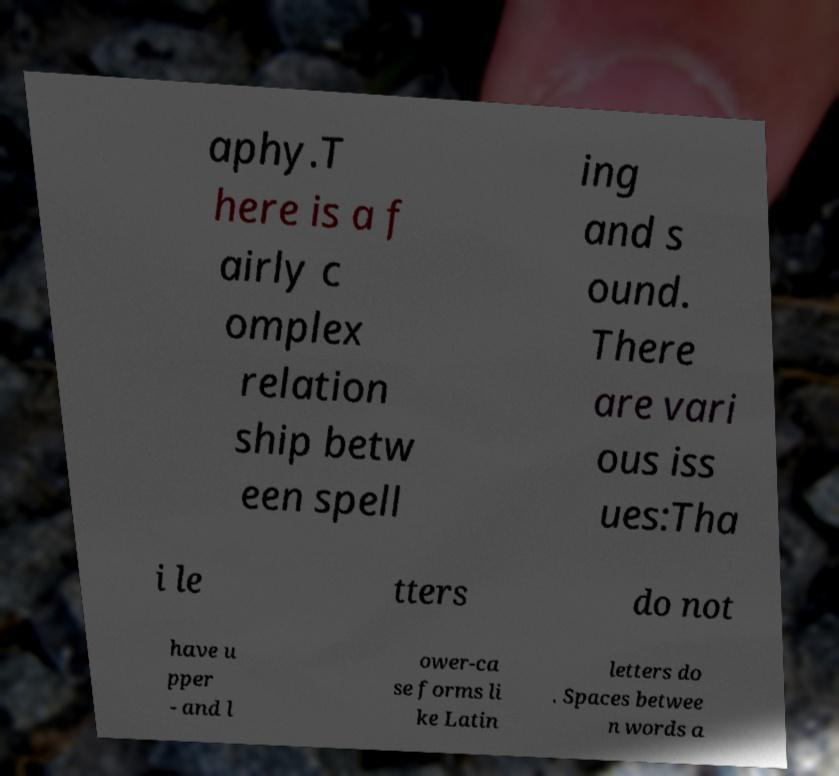Could you extract and type out the text from this image? aphy.T here is a f airly c omplex relation ship betw een spell ing and s ound. There are vari ous iss ues:Tha i le tters do not have u pper - and l ower-ca se forms li ke Latin letters do . Spaces betwee n words a 